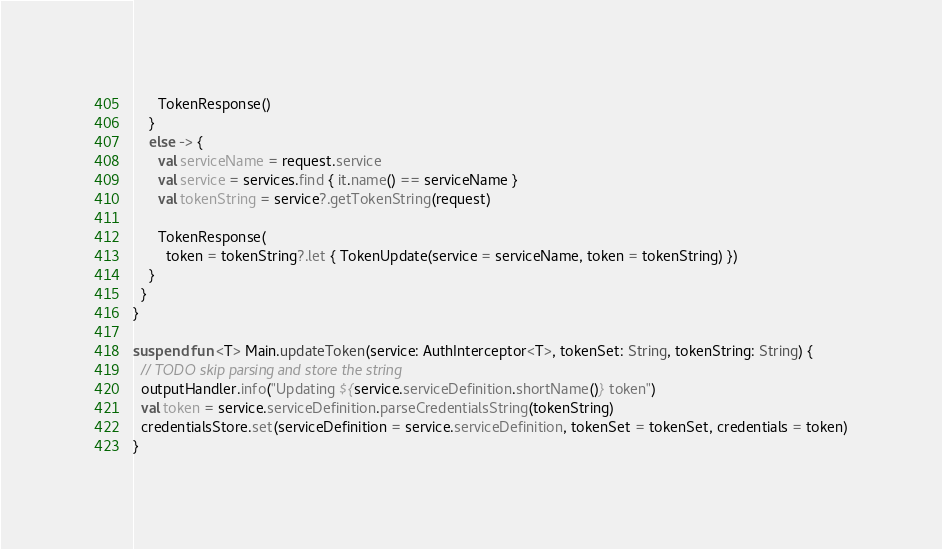<code> <loc_0><loc_0><loc_500><loc_500><_Kotlin_>      TokenResponse()
    }
    else -> {
      val serviceName = request.service
      val service = services.find { it.name() == serviceName }
      val tokenString = service?.getTokenString(request)

      TokenResponse(
        token = tokenString?.let { TokenUpdate(service = serviceName, token = tokenString) })
    }
  }
}

suspend fun <T> Main.updateToken(service: AuthInterceptor<T>, tokenSet: String, tokenString: String) {
  // TODO skip parsing and store the string
  outputHandler.info("Updating ${service.serviceDefinition.shortName()} token")
  val token = service.serviceDefinition.parseCredentialsString(tokenString)
  credentialsStore.set(serviceDefinition = service.serviceDefinition, tokenSet = tokenSet, credentials = token)
}
</code> 